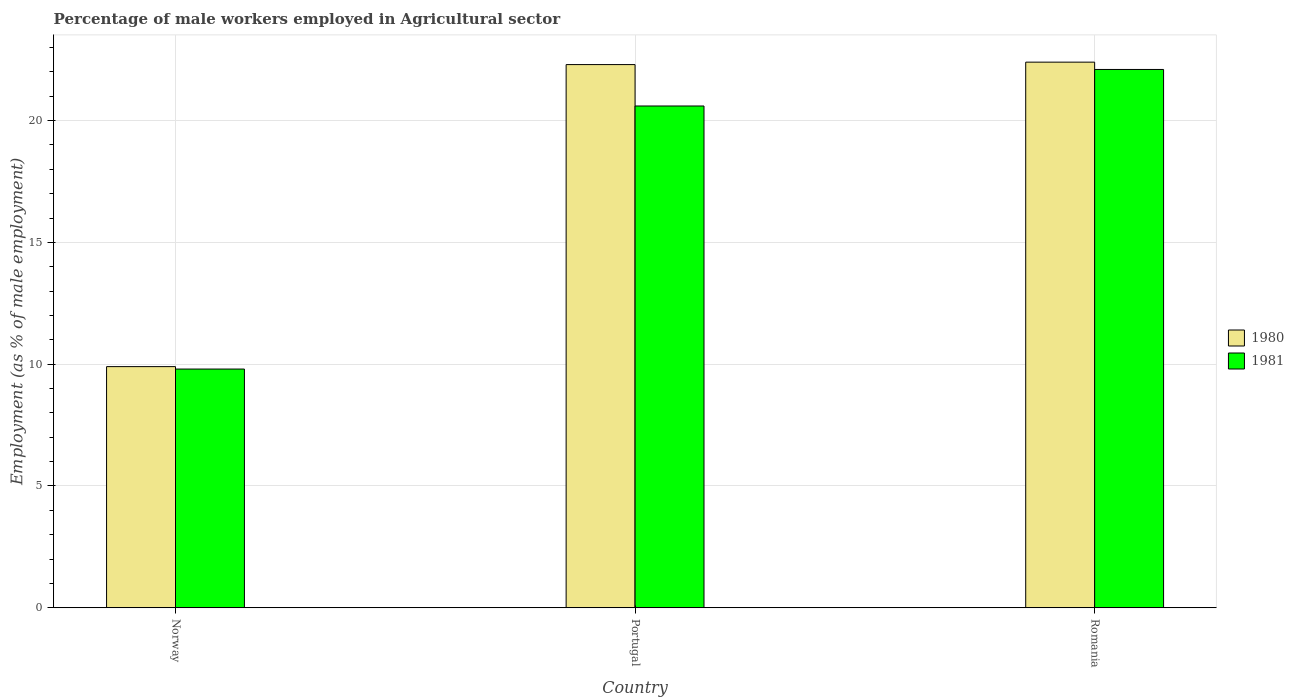Are the number of bars on each tick of the X-axis equal?
Offer a terse response. Yes. How many bars are there on the 3rd tick from the left?
Offer a terse response. 2. How many bars are there on the 2nd tick from the right?
Your answer should be compact. 2. What is the label of the 3rd group of bars from the left?
Make the answer very short. Romania. What is the percentage of male workers employed in Agricultural sector in 1981 in Romania?
Give a very brief answer. 22.1. Across all countries, what is the maximum percentage of male workers employed in Agricultural sector in 1981?
Your answer should be compact. 22.1. Across all countries, what is the minimum percentage of male workers employed in Agricultural sector in 1980?
Your response must be concise. 9.9. In which country was the percentage of male workers employed in Agricultural sector in 1980 maximum?
Your answer should be very brief. Romania. What is the total percentage of male workers employed in Agricultural sector in 1981 in the graph?
Ensure brevity in your answer.  52.5. What is the difference between the percentage of male workers employed in Agricultural sector in 1981 in Norway and that in Romania?
Your answer should be very brief. -12.3. What is the difference between the percentage of male workers employed in Agricultural sector in 1981 in Romania and the percentage of male workers employed in Agricultural sector in 1980 in Norway?
Your answer should be very brief. 12.2. What is the average percentage of male workers employed in Agricultural sector in 1980 per country?
Your answer should be very brief. 18.2. What is the difference between the percentage of male workers employed in Agricultural sector of/in 1981 and percentage of male workers employed in Agricultural sector of/in 1980 in Romania?
Your response must be concise. -0.3. In how many countries, is the percentage of male workers employed in Agricultural sector in 1981 greater than 14 %?
Offer a terse response. 2. What is the ratio of the percentage of male workers employed in Agricultural sector in 1981 in Norway to that in Romania?
Your answer should be very brief. 0.44. Is the percentage of male workers employed in Agricultural sector in 1980 in Portugal less than that in Romania?
Offer a terse response. Yes. Is the difference between the percentage of male workers employed in Agricultural sector in 1981 in Norway and Portugal greater than the difference between the percentage of male workers employed in Agricultural sector in 1980 in Norway and Portugal?
Provide a short and direct response. Yes. What is the difference between the highest and the second highest percentage of male workers employed in Agricultural sector in 1981?
Provide a short and direct response. -10.8. What is the difference between the highest and the lowest percentage of male workers employed in Agricultural sector in 1981?
Keep it short and to the point. 12.3. What does the 1st bar from the left in Norway represents?
Keep it short and to the point. 1980. What does the 1st bar from the right in Romania represents?
Ensure brevity in your answer.  1981. How many countries are there in the graph?
Provide a short and direct response. 3. What is the difference between two consecutive major ticks on the Y-axis?
Provide a short and direct response. 5. Does the graph contain grids?
Your answer should be very brief. Yes. Where does the legend appear in the graph?
Ensure brevity in your answer.  Center right. How many legend labels are there?
Make the answer very short. 2. How are the legend labels stacked?
Give a very brief answer. Vertical. What is the title of the graph?
Your answer should be very brief. Percentage of male workers employed in Agricultural sector. Does "1988" appear as one of the legend labels in the graph?
Your response must be concise. No. What is the label or title of the Y-axis?
Ensure brevity in your answer.  Employment (as % of male employment). What is the Employment (as % of male employment) of 1980 in Norway?
Make the answer very short. 9.9. What is the Employment (as % of male employment) of 1981 in Norway?
Offer a very short reply. 9.8. What is the Employment (as % of male employment) of 1980 in Portugal?
Offer a terse response. 22.3. What is the Employment (as % of male employment) in 1981 in Portugal?
Your response must be concise. 20.6. What is the Employment (as % of male employment) of 1980 in Romania?
Your response must be concise. 22.4. What is the Employment (as % of male employment) in 1981 in Romania?
Offer a very short reply. 22.1. Across all countries, what is the maximum Employment (as % of male employment) of 1980?
Offer a terse response. 22.4. Across all countries, what is the maximum Employment (as % of male employment) of 1981?
Provide a succinct answer. 22.1. Across all countries, what is the minimum Employment (as % of male employment) of 1980?
Provide a short and direct response. 9.9. Across all countries, what is the minimum Employment (as % of male employment) of 1981?
Give a very brief answer. 9.8. What is the total Employment (as % of male employment) in 1980 in the graph?
Offer a very short reply. 54.6. What is the total Employment (as % of male employment) of 1981 in the graph?
Your answer should be compact. 52.5. What is the difference between the Employment (as % of male employment) in 1981 in Norway and that in Portugal?
Offer a terse response. -10.8. What is the difference between the Employment (as % of male employment) in 1980 in Norway and that in Romania?
Your response must be concise. -12.5. What is the difference between the Employment (as % of male employment) of 1981 in Norway and that in Romania?
Your answer should be very brief. -12.3. What is the difference between the Employment (as % of male employment) in 1980 in Portugal and that in Romania?
Your response must be concise. -0.1. What is the difference between the Employment (as % of male employment) of 1981 in Portugal and that in Romania?
Your answer should be compact. -1.5. What is the difference between the Employment (as % of male employment) in 1980 in Norway and the Employment (as % of male employment) in 1981 in Portugal?
Give a very brief answer. -10.7. What is the difference between the Employment (as % of male employment) in 1980 in Norway and the Employment (as % of male employment) in 1981 in Romania?
Provide a short and direct response. -12.2. What is the difference between the Employment (as % of male employment) of 1980 in Portugal and the Employment (as % of male employment) of 1981 in Romania?
Keep it short and to the point. 0.2. What is the average Employment (as % of male employment) of 1980 per country?
Offer a very short reply. 18.2. What is the average Employment (as % of male employment) in 1981 per country?
Provide a succinct answer. 17.5. What is the difference between the Employment (as % of male employment) of 1980 and Employment (as % of male employment) of 1981 in Romania?
Offer a terse response. 0.3. What is the ratio of the Employment (as % of male employment) in 1980 in Norway to that in Portugal?
Give a very brief answer. 0.44. What is the ratio of the Employment (as % of male employment) in 1981 in Norway to that in Portugal?
Ensure brevity in your answer.  0.48. What is the ratio of the Employment (as % of male employment) of 1980 in Norway to that in Romania?
Provide a succinct answer. 0.44. What is the ratio of the Employment (as % of male employment) in 1981 in Norway to that in Romania?
Offer a terse response. 0.44. What is the ratio of the Employment (as % of male employment) of 1981 in Portugal to that in Romania?
Provide a succinct answer. 0.93. What is the difference between the highest and the second highest Employment (as % of male employment) of 1981?
Give a very brief answer. 1.5. What is the difference between the highest and the lowest Employment (as % of male employment) in 1981?
Your answer should be compact. 12.3. 